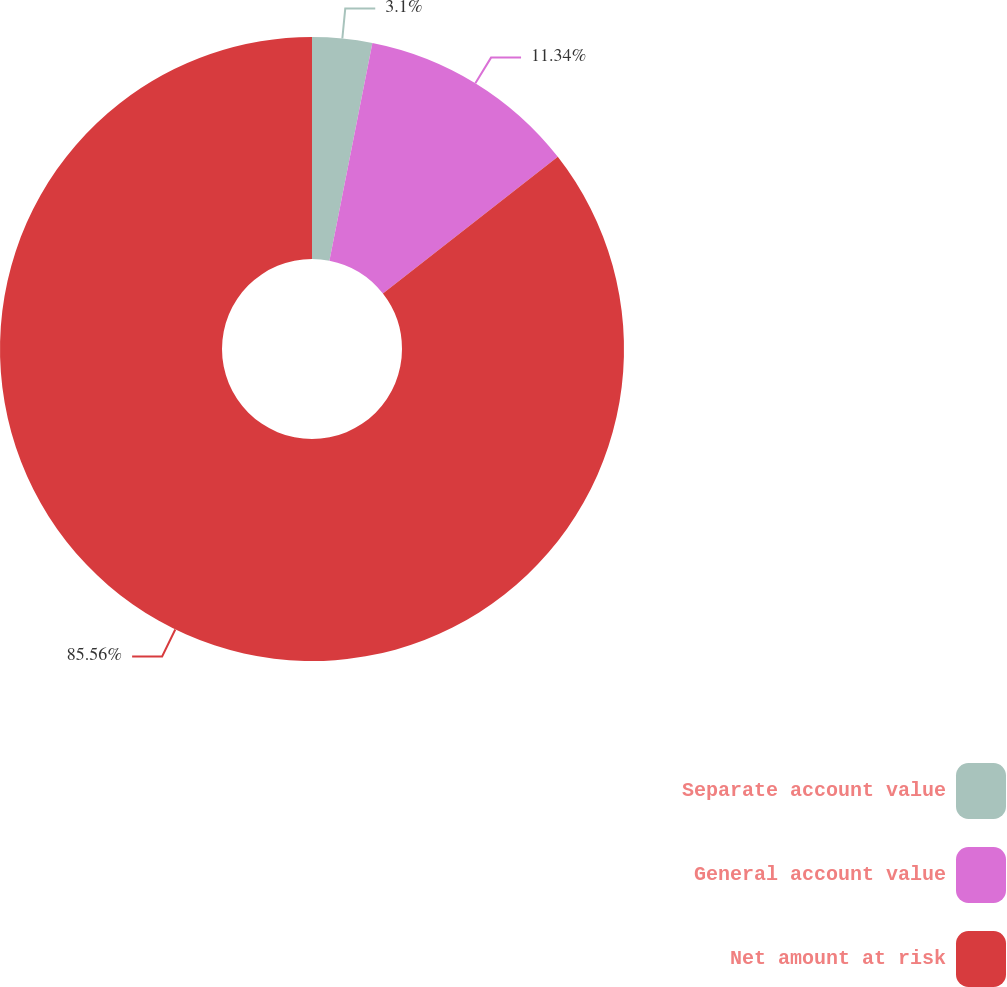Convert chart to OTSL. <chart><loc_0><loc_0><loc_500><loc_500><pie_chart><fcel>Separate account value<fcel>General account value<fcel>Net amount at risk<nl><fcel>3.1%<fcel>11.34%<fcel>85.56%<nl></chart> 